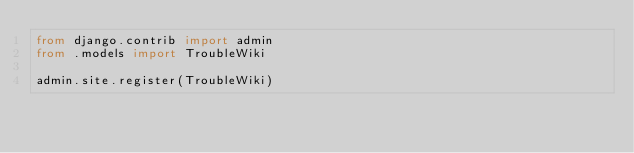<code> <loc_0><loc_0><loc_500><loc_500><_Python_>from django.contrib import admin
from .models import TroubleWiki

admin.site.register(TroubleWiki)</code> 